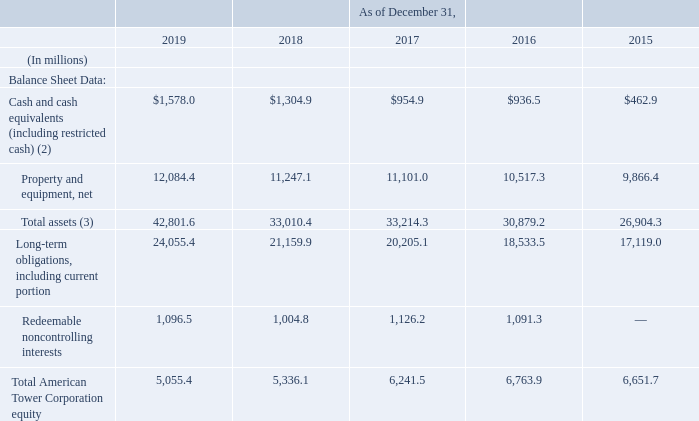ITEM 6. SELECTED FINANCIAL DATA
The selected financial data should be read in conjunction with our “Management’s Discussion and Analysis of Financial Condition and Results of Operations,” and our audited consolidated financial statements and the related notes to those consolidated financial statements included in this Annual Report.
Year-over-year comparisons are significantly affected by our acquisitions, dispositions and construction of towers. Our transaction with Verizon Communications Inc. (“Verizon” and the transaction, the “Verizon Transaction”) and the acquisition of a controlling ownership interest in Viom Networks Limited (“Viom” and the acquisition, the “Viom Acquisition”), which closed in March 2015 and April 2016, respectively, significantly impact the comparability of reported results between periods. Our principal 2019 acquisitions are described in note 7 to our consolidated financial statements included in this Annual Report.
(2) As of December 31, 2019, 2018, 2017, 2016 and 2015, amounts include $76.8 million, $96.2 million, $152.8 million, $149.3 million, and $142.2 million, respectively, of restricted funds pledged as collateral to secure obligations and cash, the use of which is otherwise limited by contractual provisions.
(3) Total assets as of December 31, 2019 includes the Right-of-use asset recognized in connection with our adoption of the new lease accounting standard described in note 1 to our consolidated financial statements included in this Annual Report
Why was Right-of-use asset included in total assets? Adoption of the new lease accounting standard described in note 1 to our consolidated financial statements included in this annual report. What was the amount of net property and equipment in 2015?
Answer scale should be: million. 9,866.4. What were the Redeemable noncontrolling interests in 2019?
Answer scale should be: million. 1,096.5. What was the change in Long-term obligations, including current portion between 2018 and 2019?
Answer scale should be: million. 24,055.4-21,159.9
Answer: 2895.5. What was the percentage change in Total American Tower Corporation equity between 2015 and 2016?
Answer scale should be: percent. (6,763.9-6,651.7)/6,651.7
Answer: 1.69. What was the change in total assets between 2017 and 2018?
Answer scale should be: million. 33,010.4-33,214.3
Answer: -203.9. 